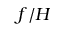Convert formula to latex. <formula><loc_0><loc_0><loc_500><loc_500>f / H</formula> 